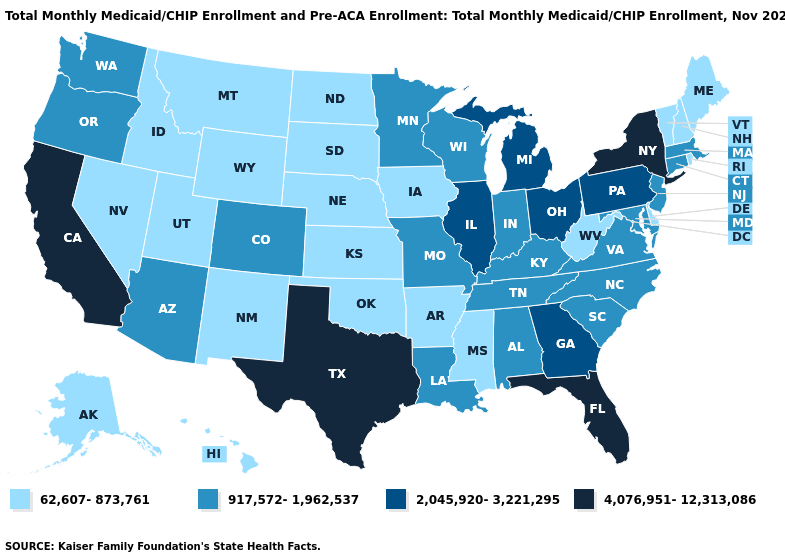Name the states that have a value in the range 917,572-1,962,537?
Short answer required. Alabama, Arizona, Colorado, Connecticut, Indiana, Kentucky, Louisiana, Maryland, Massachusetts, Minnesota, Missouri, New Jersey, North Carolina, Oregon, South Carolina, Tennessee, Virginia, Washington, Wisconsin. Which states hav the highest value in the MidWest?
Answer briefly. Illinois, Michigan, Ohio. What is the value of Nebraska?
Short answer required. 62,607-873,761. What is the value of Minnesota?
Give a very brief answer. 917,572-1,962,537. Does the map have missing data?
Short answer required. No. What is the highest value in the USA?
Short answer required. 4,076,951-12,313,086. What is the value of Tennessee?
Write a very short answer. 917,572-1,962,537. Does the map have missing data?
Keep it brief. No. Name the states that have a value in the range 917,572-1,962,537?
Give a very brief answer. Alabama, Arizona, Colorado, Connecticut, Indiana, Kentucky, Louisiana, Maryland, Massachusetts, Minnesota, Missouri, New Jersey, North Carolina, Oregon, South Carolina, Tennessee, Virginia, Washington, Wisconsin. How many symbols are there in the legend?
Concise answer only. 4. What is the value of Wisconsin?
Write a very short answer. 917,572-1,962,537. What is the highest value in the South ?
Concise answer only. 4,076,951-12,313,086. What is the value of Maryland?
Give a very brief answer. 917,572-1,962,537. How many symbols are there in the legend?
Keep it brief. 4. Name the states that have a value in the range 62,607-873,761?
Keep it brief. Alaska, Arkansas, Delaware, Hawaii, Idaho, Iowa, Kansas, Maine, Mississippi, Montana, Nebraska, Nevada, New Hampshire, New Mexico, North Dakota, Oklahoma, Rhode Island, South Dakota, Utah, Vermont, West Virginia, Wyoming. 